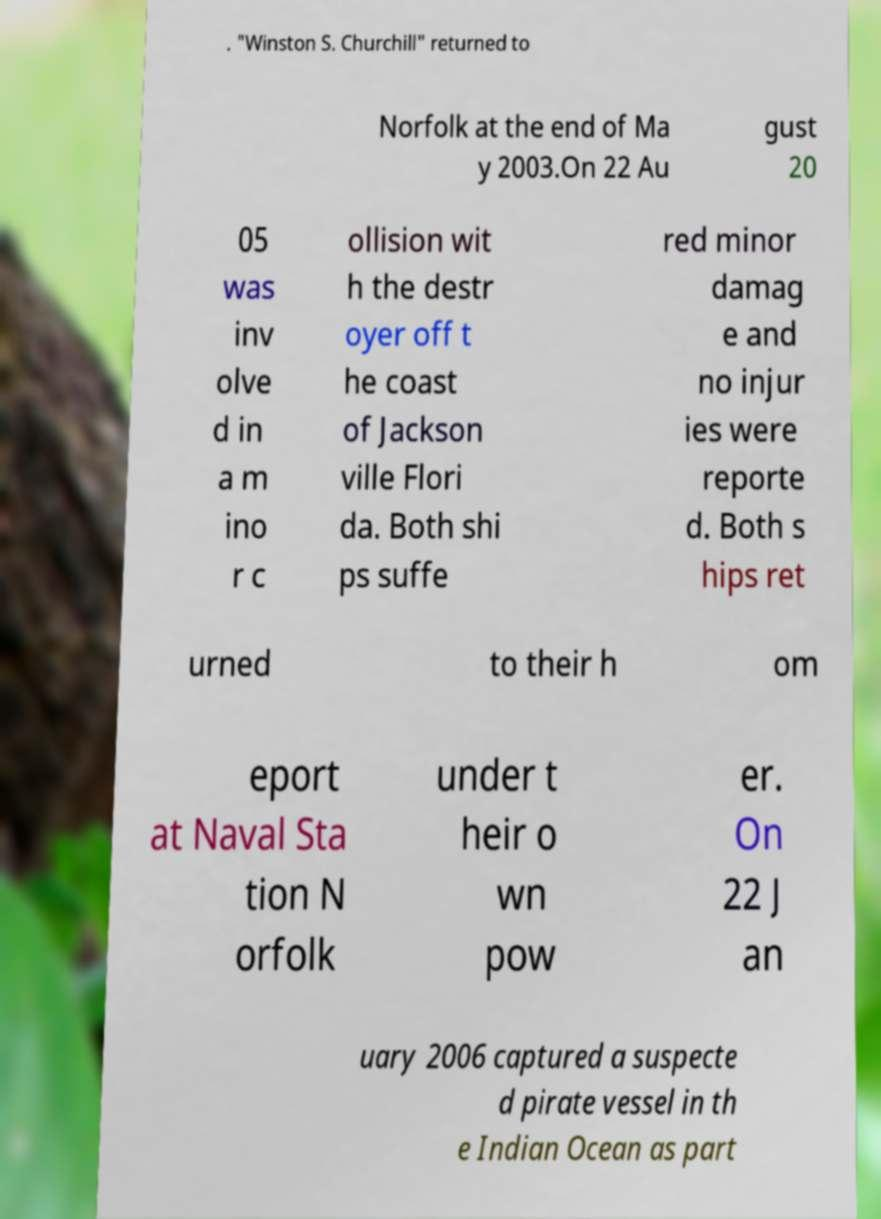For documentation purposes, I need the text within this image transcribed. Could you provide that? . "Winston S. Churchill" returned to Norfolk at the end of Ma y 2003.On 22 Au gust 20 05 was inv olve d in a m ino r c ollision wit h the destr oyer off t he coast of Jackson ville Flori da. Both shi ps suffe red minor damag e and no injur ies were reporte d. Both s hips ret urned to their h om eport at Naval Sta tion N orfolk under t heir o wn pow er. On 22 J an uary 2006 captured a suspecte d pirate vessel in th e Indian Ocean as part 